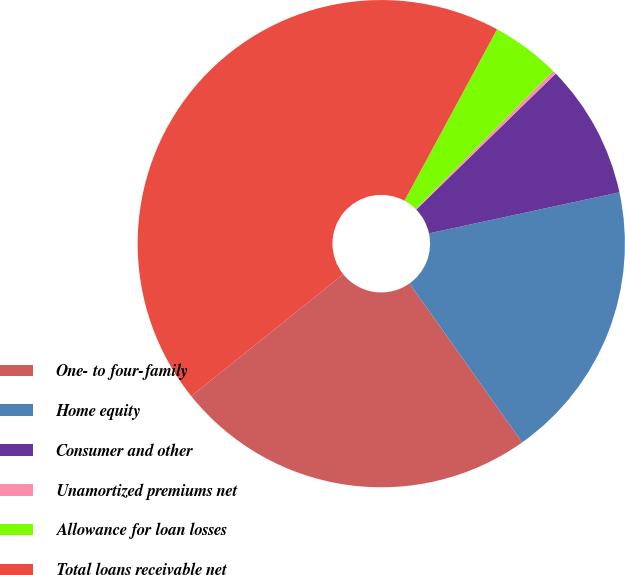<chart> <loc_0><loc_0><loc_500><loc_500><pie_chart><fcel>One- to four-family<fcel>Home equity<fcel>Consumer and other<fcel>Unamortized premiums net<fcel>Allowance for loan losses<fcel>Total loans receivable net<nl><fcel>24.05%<fcel>18.56%<fcel>8.92%<fcel>0.24%<fcel>4.58%<fcel>43.65%<nl></chart> 